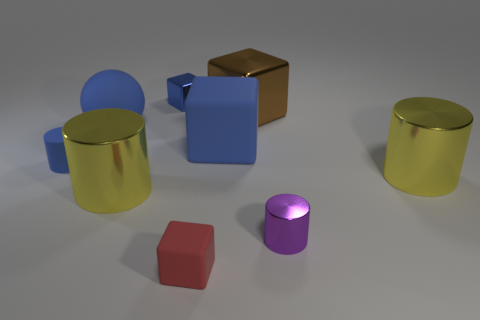Subtract all brown cylinders. Subtract all red blocks. How many cylinders are left? 4 Subtract all balls. How many objects are left? 8 Add 8 tiny purple objects. How many tiny purple objects exist? 9 Subtract 0 yellow cubes. How many objects are left? 9 Subtract all big blue blocks. Subtract all blue objects. How many objects are left? 4 Add 8 brown things. How many brown things are left? 9 